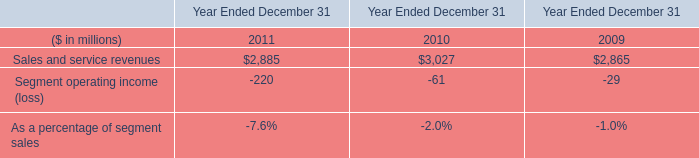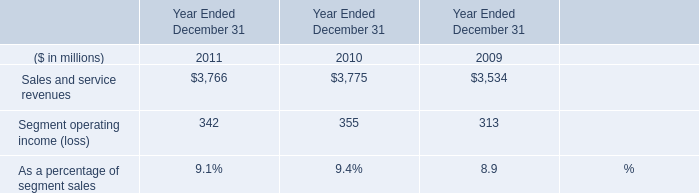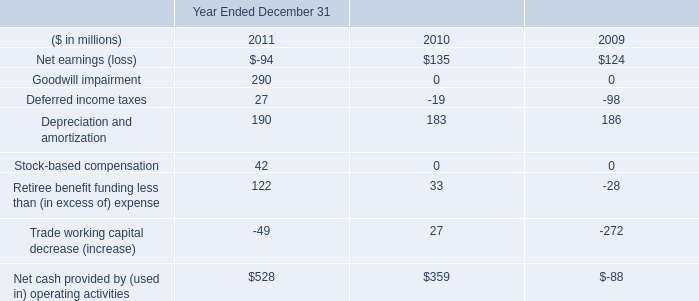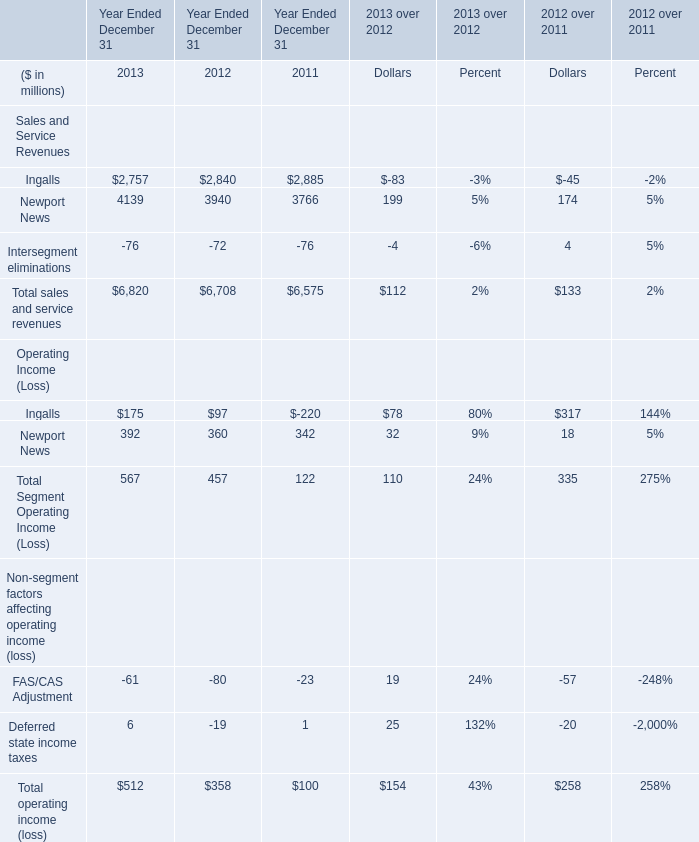What is the ratio of Ingalls of Sales and Service Revenues to the Sales and service revenues in Table 1 in 2011? 
Computations: (2885 / 3766)
Answer: 0.76606. 